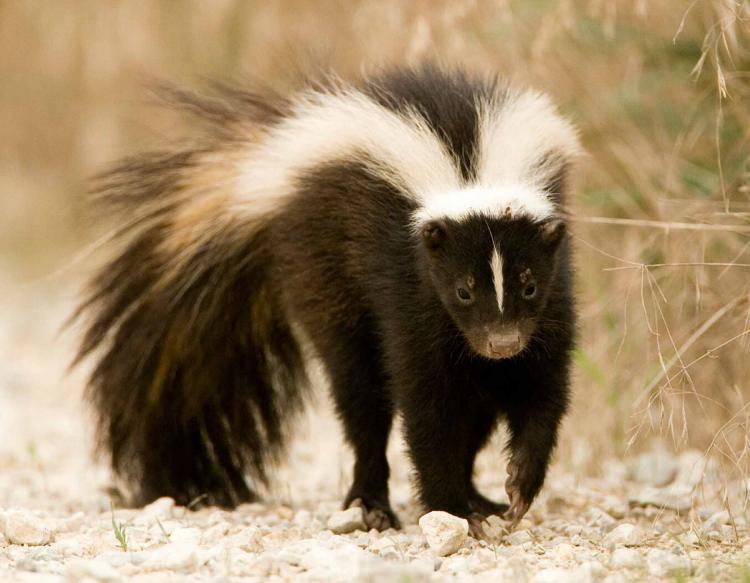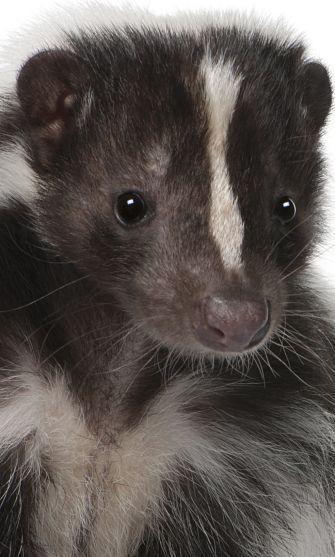The first image is the image on the left, the second image is the image on the right. Assess this claim about the two images: "The left and right image contains the same number of live skunks with at least one sitting on a white floor.". Correct or not? Answer yes or no. No. 